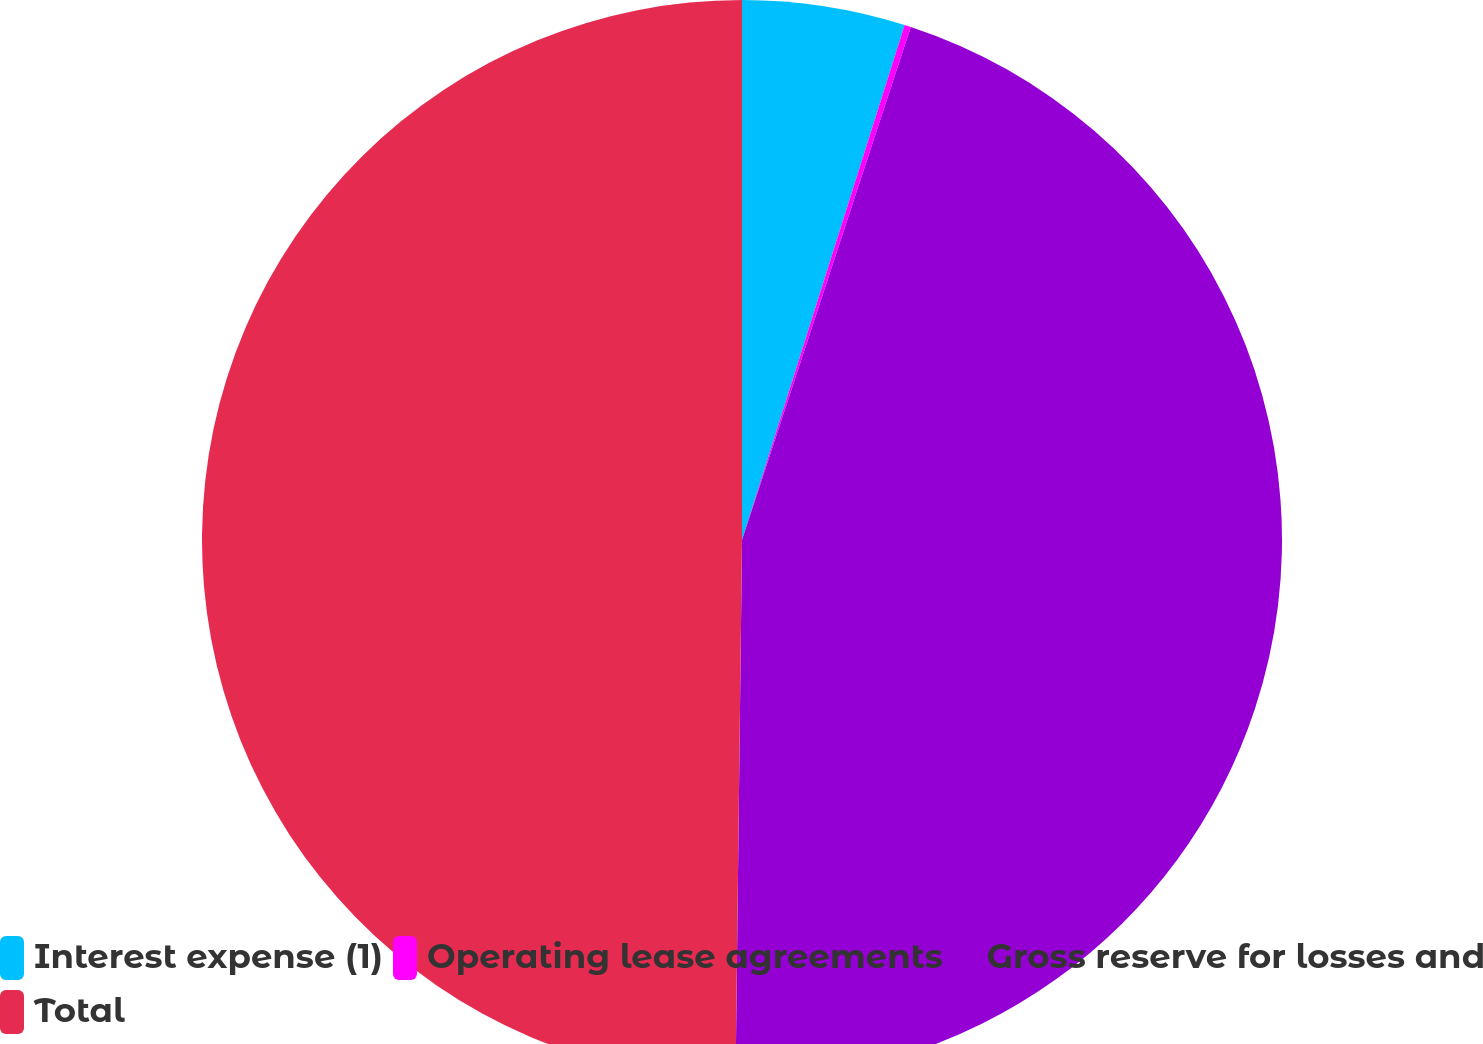Convert chart to OTSL. <chart><loc_0><loc_0><loc_500><loc_500><pie_chart><fcel>Interest expense (1)<fcel>Operating lease agreements<fcel>Gross reserve for losses and<fcel>Total<nl><fcel>4.87%<fcel>0.19%<fcel>45.13%<fcel>49.81%<nl></chart> 